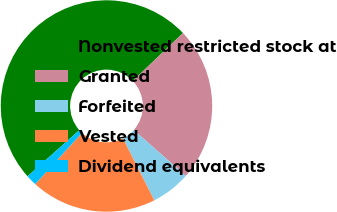Convert chart. <chart><loc_0><loc_0><loc_500><loc_500><pie_chart><fcel>Nonvested restricted stock at<fcel>Granted<fcel>Forfeited<fcel>Vested<fcel>Dividend equivalents<nl><fcel>49.45%<fcel>23.63%<fcel>6.04%<fcel>19.23%<fcel>1.65%<nl></chart> 